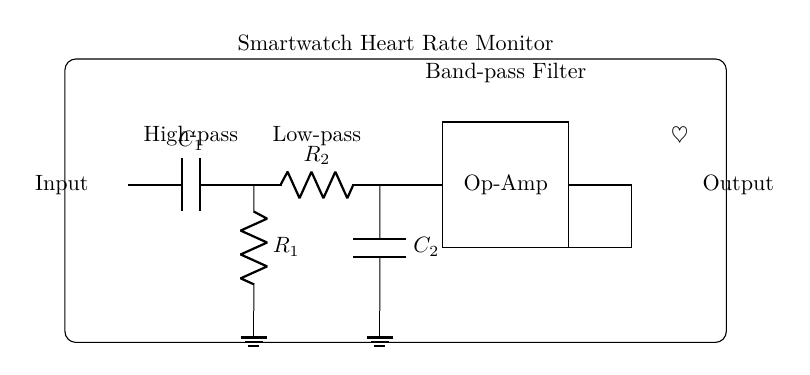What components are in the high-pass filter section? The high-pass filter section only contains one capacitor labeled C1 and one resistor labeled R1. These two components are connected in series, where C1 is connected to the input and R1 is connected to ground.
Answer: C1, R1 What is the role of the op-amp in this circuit? The operational amplifier (op-amp) serves as an amplification stage in the circuit, enhancing the output signal that has been filtered by the preceding high-pass and low-pass sections. It takes the processed input from the low-pass section and amplifies it to provide a stronger output signal.
Answer: Amplification How many resistors are in the entire circuit? There are two resistors present in the circuit: R1 in the high-pass filter section and R2 in the low-pass filter section. Each resistor plays a distinct role within their respective filter sections to define the filtering characteristics of the circuit.
Answer: 2 Which component connects the high-pass filter to the low-pass filter? The common connection between the high-pass filter section and the low-pass filter section is through the point where R1 and R2 are linked. This allows the output from the high-pass filter to be fed directly into the input of the low-pass filter.
Answer: R2 What does the heart rate symbol in the diagram represent? The heart rate symbol represents the functionality of the entire circuit, indicating that this filter configuration is specifically designed for heart rate monitoring applications within the smartwatch. It emphasizes the purpose of the circuit as a heart rate monitoring tool.
Answer: Heart rate monitoring What type of filter is this circuit designed to be? This circuit is specifically designed as a band-pass filter, which is evident from the arrangement of the high-pass and low-pass filter components followed by an amplification stage. This configuration allows it to filter signals within a specific frequency range, suitable for heart rate detection.
Answer: Band-pass filter 